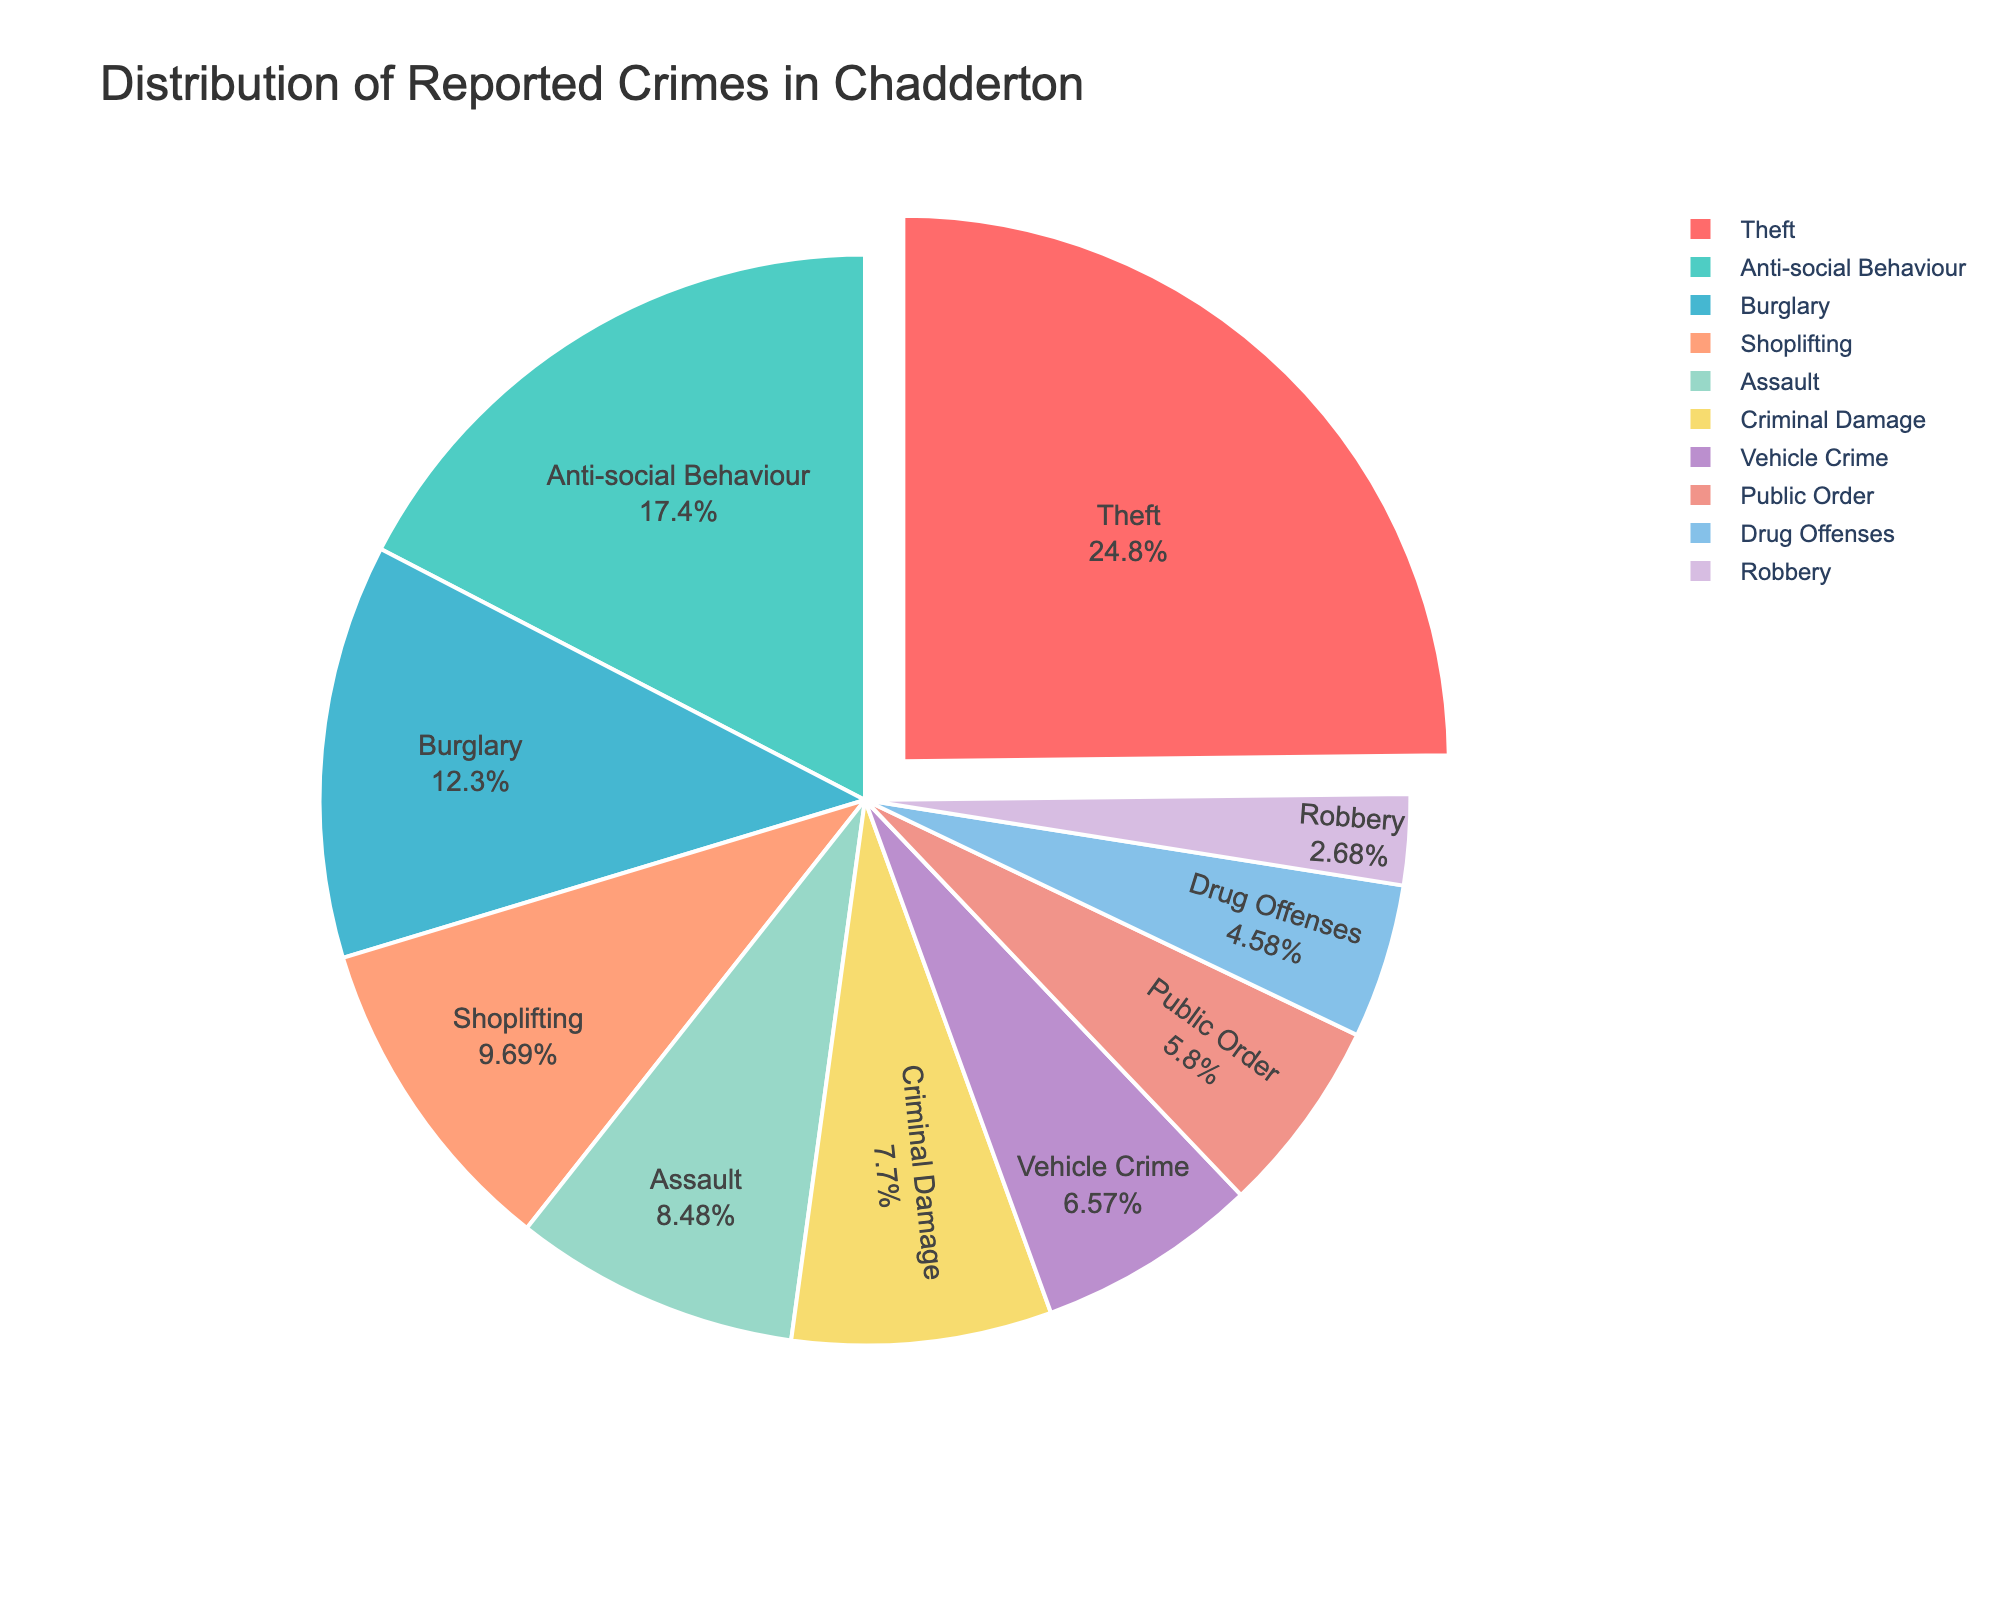What percentage of reported crimes in Chadderton is theft? The pie chart gives the percentage for each crime type. According to the chart, theft represents a specific percentage of the whole.
Answer: 28.7% Which crime type has the second highest number of reported cases? The pie chart segments reflect the number of reported cases in descending order, after theft, the second largest slice on the chart represents Anti-social Behaviour.
Answer: Anti-social Behaviour How many reported theft and burglary cases are there combined? To find the total, sum the reported cases of theft and burglary: 287 (theft) + 142 (burglary)
Answer: 429 What is the difference in the number of reported cases between assault and vehicle crime? Subtract the number of reported cases of vehicle crime from the reported cases of assault: 98 (assault) - 76 (vehicle crime)
Answer: 22 Which crime types have fewer reported cases than shoplifting? The pie chart allows a comparison of segments. The crime types with smaller segments than shoplifting are Drug Offenses, Public Order, and Robbery.
Answer: Drug Offenses, Public Order, Robbery Which crime type contributes approximately half of the number of reported theft cases? From the pie chart, burglary is approximately half of the number of reported theft cases (142 compared to 287 is close to half).
Answer: Burglary What percentage of reported crimes are vehicle crime and shoplifting combined? The pie chart gives percentages. Adding the percentages of vehicle crime and shoplifting from the chart gives the combined total.
Answer: 7.6% + 11.2% = 18.8% If the reported cases are split into two nearly equal groups, which crime types fall into the smaller group? By viewing the chart, split the categories approximately equally by rearranging segments by size. The smaller group includes all categories from Criminal Damage down.
Answer: Criminal Damage, Drug Offenses, Public Order, Robbery What is the approximate combined percentage of theft, anti-social behaviour, and shoplifting? Sum the percentages of these three types from the chart for an approximation.
Answer: 28.7% + 20.1% + 11.2% ≈ 60% How does the number of reported robbery cases compare to the reported public order cases? The pie chart allows a visual comparison. Robbery has fewer reported cases than public order.
Answer: Fewer 